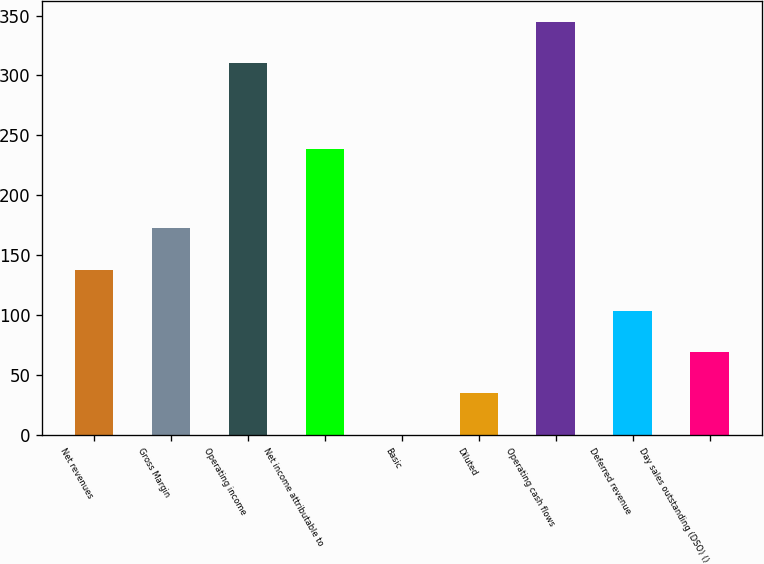Convert chart. <chart><loc_0><loc_0><loc_500><loc_500><bar_chart><fcel>Net revenues<fcel>Gross Margin<fcel>Operating income<fcel>Net income attributable to<fcel>Basic<fcel>Diluted<fcel>Operating cash flows<fcel>Deferred revenue<fcel>Day sales outstanding (DSO) ()<nl><fcel>138<fcel>172.39<fcel>310.4<fcel>238.6<fcel>0.44<fcel>34.83<fcel>344.79<fcel>103.61<fcel>69.22<nl></chart> 